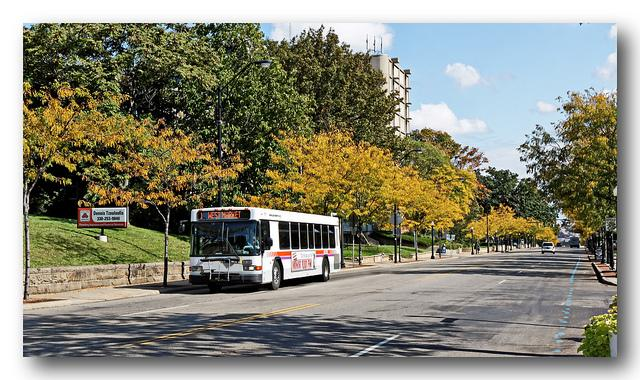What color is the line on the floor that is all the way to the right? blue 